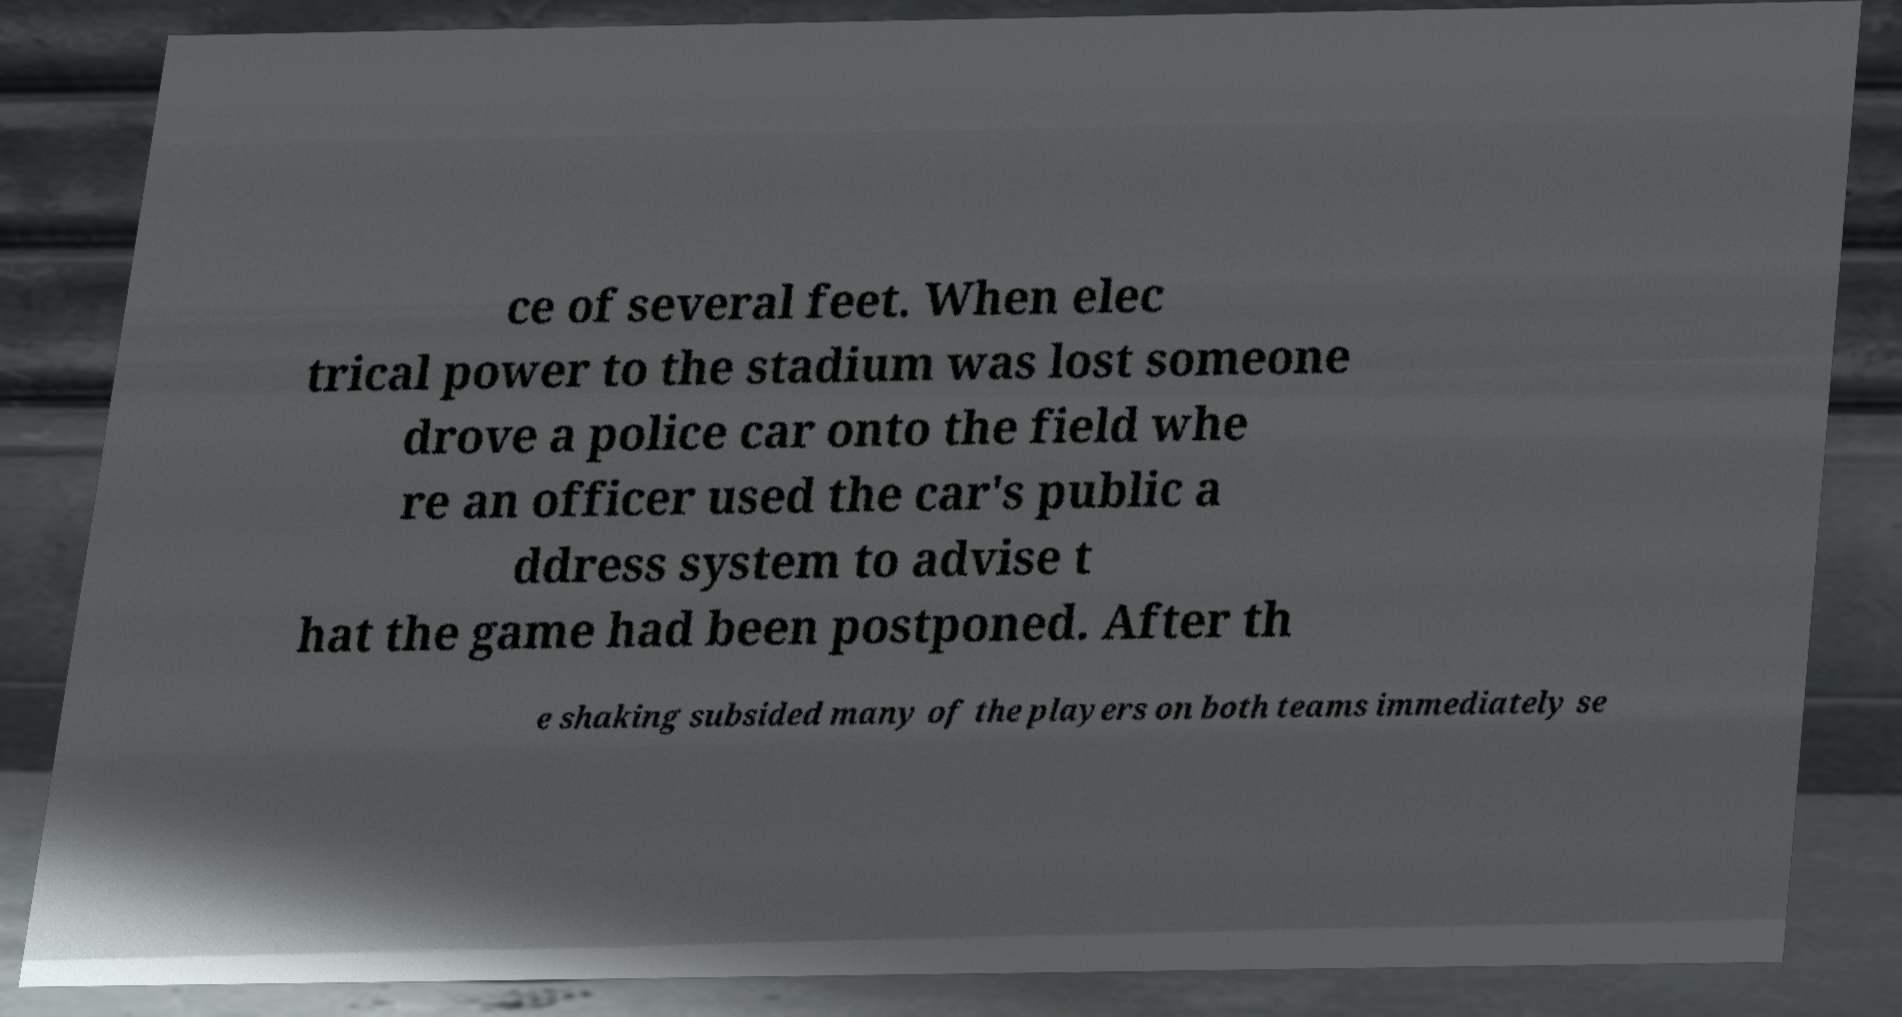For documentation purposes, I need the text within this image transcribed. Could you provide that? ce of several feet. When elec trical power to the stadium was lost someone drove a police car onto the field whe re an officer used the car's public a ddress system to advise t hat the game had been postponed. After th e shaking subsided many of the players on both teams immediately se 